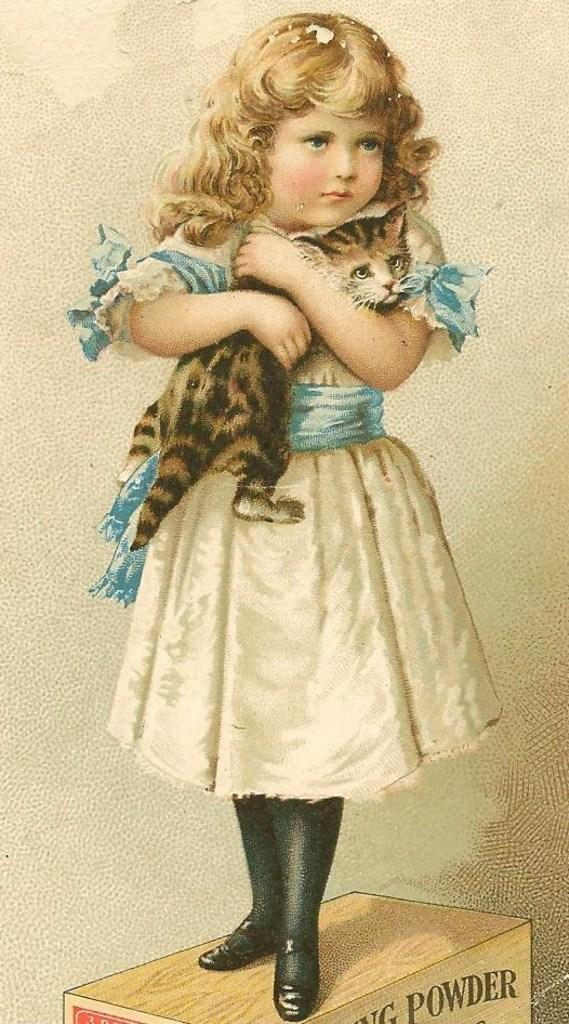What is the main subject of the image? There is a photo in the image. What can be seen in the photo? The photo contains a girl. What is the girl doing in the photo? The girl is standing on a wooden object. What is the girl holding in the photo? The girl is holding a cat in the photo. What type of button is visible on the cat's collar in the image? There is no button visible on the cat's collar in the image, as the cat is not wearing a collar. What type of plants can be seen in the background of the photo? There is no information about plants in the background of the photo, as the focus is on the girl and the cat. 